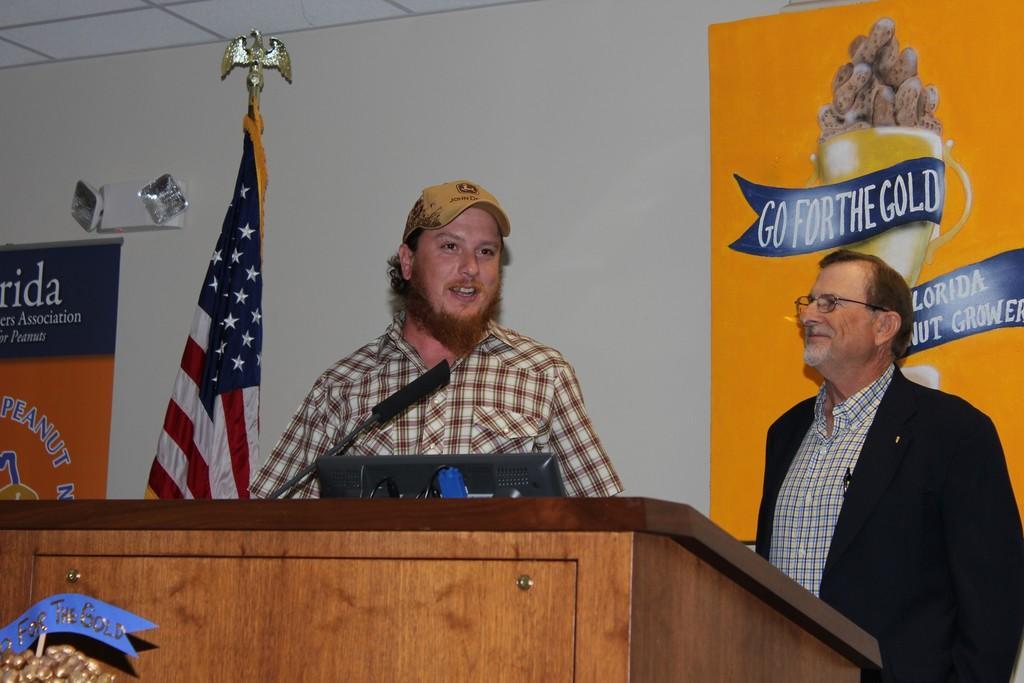Describe this image in one or two sentences. There are two men standing at the podium. On the podium there is a microphone,cables and a monitor. In the background we can see hoardings,flag and lights on the wall and on the flag we can see a sculpture of a eagle. On the left at the bottom corner there is an object. 